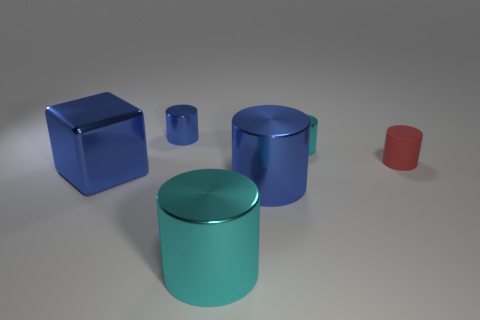Are there any tiny cylinders that are to the right of the cyan metallic thing that is behind the tiny red cylinder?
Offer a very short reply. Yes. Are there any things that have the same size as the red rubber cylinder?
Make the answer very short. Yes. There is a shiny cylinder behind the small cyan thing; is it the same color as the cube?
Make the answer very short. Yes. What is the size of the metal cube?
Your response must be concise. Large. There is a blue thing that is in front of the large shiny block that is to the left of the tiny rubber cylinder; how big is it?
Offer a very short reply. Large. How many large cubes are the same color as the matte thing?
Keep it short and to the point. 0. How many blue metal objects are there?
Keep it short and to the point. 3. How many large cyan things are the same material as the big blue cube?
Make the answer very short. 1. What is the size of the red rubber object that is the same shape as the tiny blue metallic object?
Offer a very short reply. Small. What is the blue block made of?
Provide a succinct answer. Metal. 